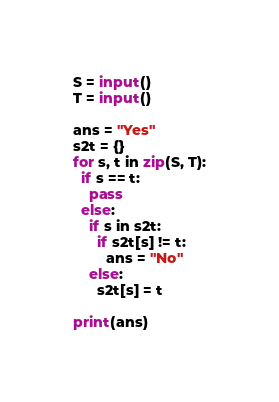Convert code to text. <code><loc_0><loc_0><loc_500><loc_500><_Python_>S = input()
T = input()

ans = "Yes"
s2t = {}
for s, t in zip(S, T):
  if s == t:
    pass
  else:
    if s in s2t:
      if s2t[s] != t:
        ans = "No"
    else:
      s2t[s] = t

print(ans)
</code> 